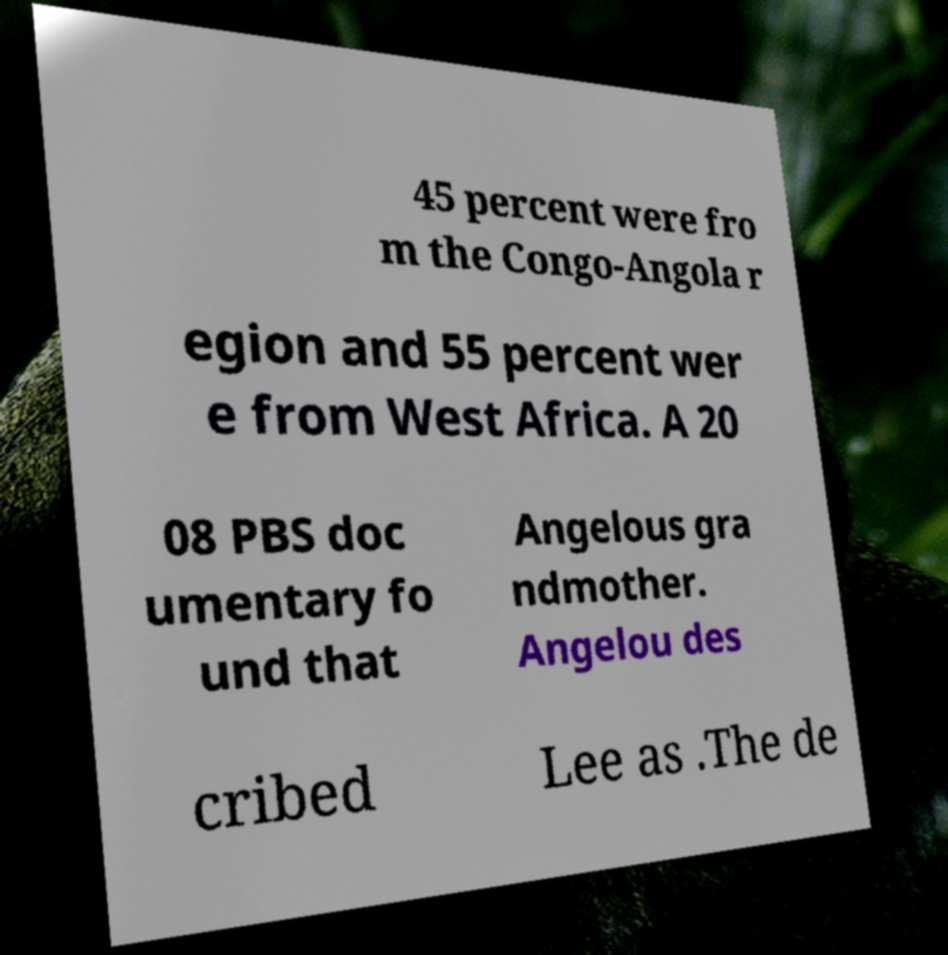What messages or text are displayed in this image? I need them in a readable, typed format. 45 percent were fro m the Congo-Angola r egion and 55 percent wer e from West Africa. A 20 08 PBS doc umentary fo und that Angelous gra ndmother. Angelou des cribed Lee as .The de 